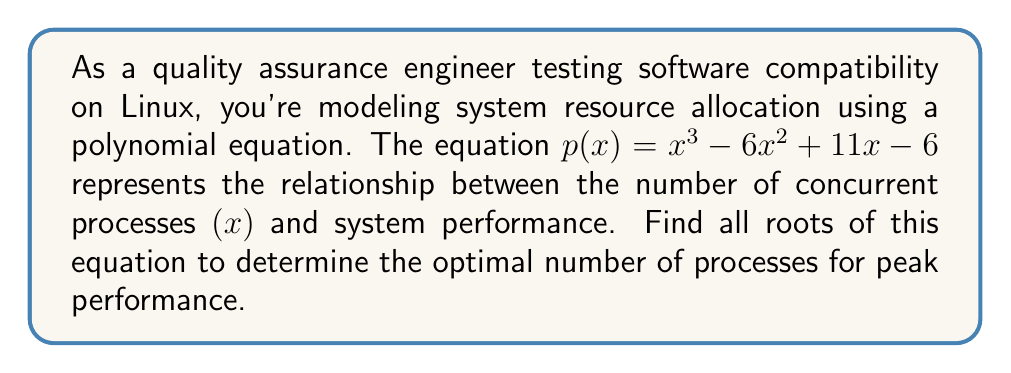Show me your answer to this math problem. To find the roots of the polynomial equation $p(x) = x^3 - 6x^2 + 11x - 6$, we'll use the rational root theorem and synthetic division.

1) Potential rational roots: Factors of the constant term (6) divided by factors of the leading coefficient (1)
   Potential roots: $\pm 1, \pm 2, \pm 3, \pm 6$

2) Test these potential roots using synthetic division:

   Testing $x = 1$:
   $$
   \begin{array}{r}
     1 \enclose{longdiv}{1 \quad -6 \quad 11 \quad -6} \\
       \underline{1 \quad -5 \quad 6} \\
       0 \quad 5 \quad 0
   \end{array}
   $$

   We find that $x = 1$ is a root.

3) Divide the polynomial by $(x - 1)$ to get the quadratic factor:
   $x^3 - 6x^2 + 11x - 6 = (x - 1)(x^2 - 5x + 6)$

4) Solve the quadratic equation $x^2 - 5x + 6 = 0$:
   Using the quadratic formula: $x = \frac{-b \pm \sqrt{b^2 - 4ac}}{2a}$
   
   $x = \frac{5 \pm \sqrt{25 - 24}}{2} = \frac{5 \pm 1}{2}$

   This gives us $x = 3$ and $x = 2$

Therefore, the roots of the equation are $x = 1$, $x = 2$, and $x = 3$.
Answer: The roots of the polynomial equation $p(x) = x^3 - 6x^2 + 11x - 6$ are $x = 1$, $x = 2$, and $x = 3$. These represent the optimal numbers of concurrent processes for peak system performance. 